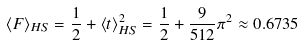Convert formula to latex. <formula><loc_0><loc_0><loc_500><loc_500>\langle F \rangle _ { H S } = \frac { 1 } { 2 } + \langle t \rangle _ { H S } ^ { 2 } = \frac { 1 } { 2 } + \frac { 9 } { 5 1 2 } \pi ^ { 2 } \approx 0 . 6 7 3 5</formula> 